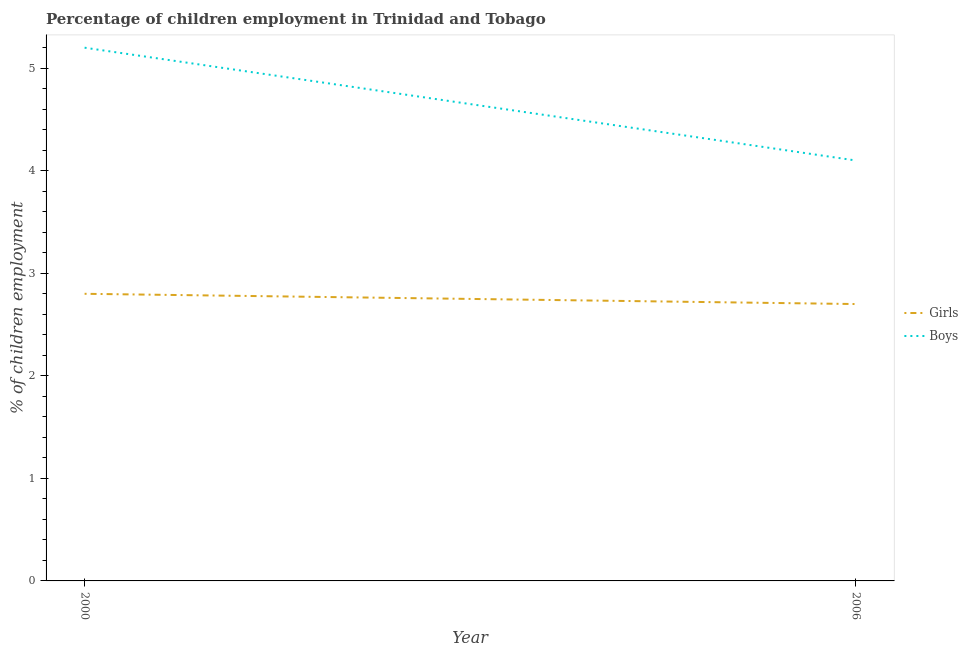Is the number of lines equal to the number of legend labels?
Provide a succinct answer. Yes. What is the percentage of employed boys in 2006?
Your answer should be compact. 4.1. In which year was the percentage of employed boys maximum?
Your response must be concise. 2000. What is the difference between the percentage of employed boys in 2000 and that in 2006?
Ensure brevity in your answer.  1.1. What is the difference between the percentage of employed girls in 2006 and the percentage of employed boys in 2000?
Keep it short and to the point. -2.5. What is the average percentage of employed girls per year?
Keep it short and to the point. 2.75. In the year 2000, what is the difference between the percentage of employed boys and percentage of employed girls?
Provide a succinct answer. 2.4. What is the ratio of the percentage of employed girls in 2000 to that in 2006?
Your answer should be very brief. 1.04. Is the percentage of employed girls in 2000 less than that in 2006?
Offer a terse response. No. Is the percentage of employed boys strictly greater than the percentage of employed girls over the years?
Keep it short and to the point. Yes. Is the percentage of employed girls strictly less than the percentage of employed boys over the years?
Offer a terse response. Yes. How many lines are there?
Your answer should be very brief. 2. Are the values on the major ticks of Y-axis written in scientific E-notation?
Provide a succinct answer. No. Does the graph contain any zero values?
Your response must be concise. No. Does the graph contain grids?
Provide a succinct answer. No. Where does the legend appear in the graph?
Provide a short and direct response. Center right. What is the title of the graph?
Your response must be concise. Percentage of children employment in Trinidad and Tobago. Does "Taxes on exports" appear as one of the legend labels in the graph?
Provide a short and direct response. No. What is the label or title of the X-axis?
Give a very brief answer. Year. What is the label or title of the Y-axis?
Keep it short and to the point. % of children employment. What is the % of children employment in Girls in 2000?
Keep it short and to the point. 2.8. What is the % of children employment of Girls in 2006?
Keep it short and to the point. 2.7. Across all years, what is the maximum % of children employment of Girls?
Ensure brevity in your answer.  2.8. Across all years, what is the minimum % of children employment of Girls?
Your answer should be very brief. 2.7. What is the total % of children employment of Girls in the graph?
Make the answer very short. 5.5. What is the average % of children employment in Girls per year?
Your response must be concise. 2.75. What is the average % of children employment of Boys per year?
Keep it short and to the point. 4.65. In the year 2006, what is the difference between the % of children employment of Girls and % of children employment of Boys?
Your answer should be very brief. -1.4. What is the ratio of the % of children employment of Boys in 2000 to that in 2006?
Keep it short and to the point. 1.27. What is the difference between the highest and the second highest % of children employment in Girls?
Your answer should be very brief. 0.1. What is the difference between the highest and the second highest % of children employment of Boys?
Offer a terse response. 1.1. What is the difference between the highest and the lowest % of children employment of Boys?
Your answer should be very brief. 1.1. 